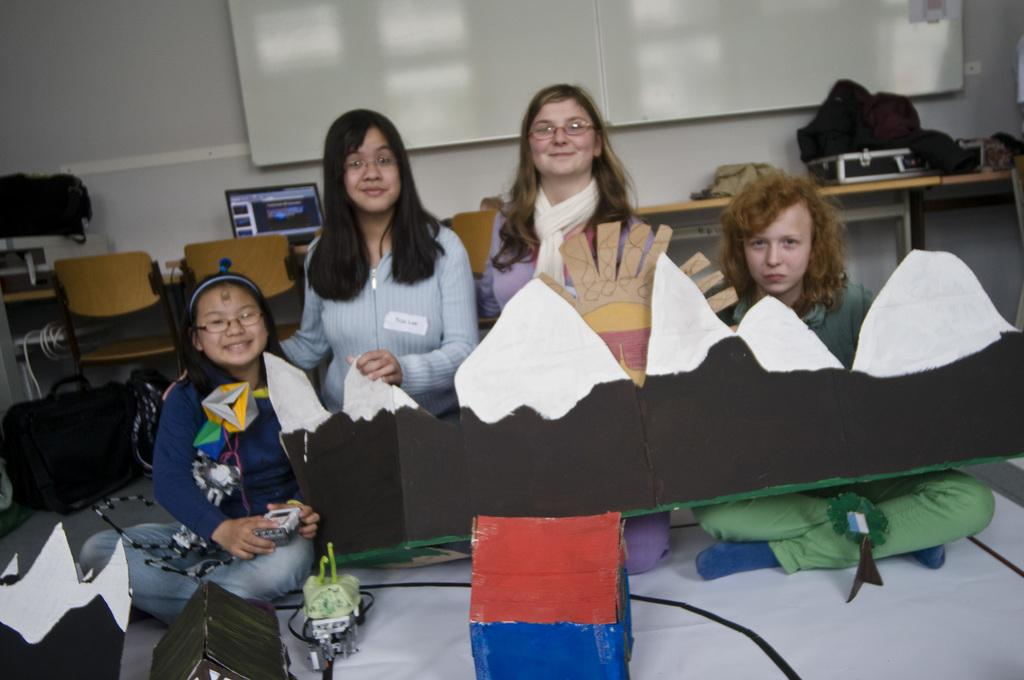How many people are in the room? There are people in the room, but the exact number is not specified. What type of furniture is in the room? There are chairs in the room. What electronic device is on the table? There is a laptop on the table. What else can be found on the table? There are objects on the table. What is attached to the wall in the room? There is a board attached to the wall. What type of storage containers are in the room? There are cardboard boxes in the room. What is the rate of the rain falling outside the room? There is no mention of rain or any outdoor environment in the image, so it is not possible to determine the rate of rain. 